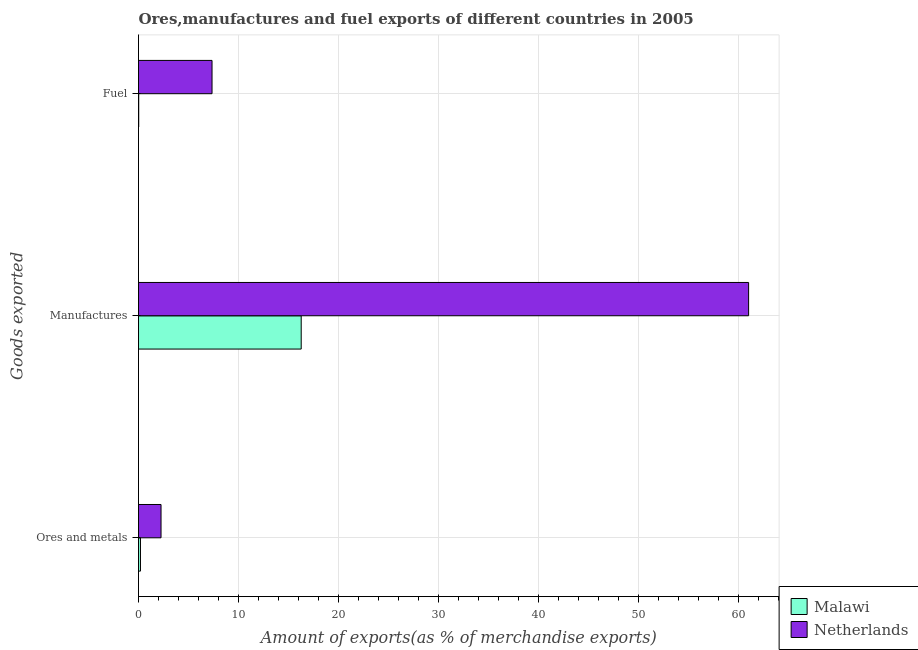How many different coloured bars are there?
Your answer should be very brief. 2. Are the number of bars on each tick of the Y-axis equal?
Your response must be concise. Yes. How many bars are there on the 3rd tick from the top?
Your answer should be very brief. 2. What is the label of the 2nd group of bars from the top?
Provide a succinct answer. Manufactures. What is the percentage of ores and metals exports in Netherlands?
Give a very brief answer. 2.25. Across all countries, what is the maximum percentage of ores and metals exports?
Give a very brief answer. 2.25. Across all countries, what is the minimum percentage of manufactures exports?
Your response must be concise. 16.27. In which country was the percentage of manufactures exports minimum?
Your answer should be compact. Malawi. What is the total percentage of ores and metals exports in the graph?
Make the answer very short. 2.45. What is the difference between the percentage of manufactures exports in Netherlands and that in Malawi?
Keep it short and to the point. 44.75. What is the difference between the percentage of fuel exports in Netherlands and the percentage of ores and metals exports in Malawi?
Provide a short and direct response. 7.16. What is the average percentage of fuel exports per country?
Your answer should be compact. 3.69. What is the difference between the percentage of manufactures exports and percentage of fuel exports in Netherlands?
Your answer should be very brief. 53.67. In how many countries, is the percentage of fuel exports greater than 16 %?
Make the answer very short. 0. What is the ratio of the percentage of fuel exports in Netherlands to that in Malawi?
Keep it short and to the point. 359.33. What is the difference between the highest and the second highest percentage of manufactures exports?
Keep it short and to the point. 44.75. What is the difference between the highest and the lowest percentage of fuel exports?
Keep it short and to the point. 7.33. What does the 2nd bar from the top in Ores and metals represents?
Offer a very short reply. Malawi. How many bars are there?
Give a very brief answer. 6. Are all the bars in the graph horizontal?
Your response must be concise. Yes. How many countries are there in the graph?
Provide a succinct answer. 2. How are the legend labels stacked?
Offer a terse response. Vertical. What is the title of the graph?
Your response must be concise. Ores,manufactures and fuel exports of different countries in 2005. What is the label or title of the X-axis?
Offer a terse response. Amount of exports(as % of merchandise exports). What is the label or title of the Y-axis?
Your answer should be compact. Goods exported. What is the Amount of exports(as % of merchandise exports) of Malawi in Ores and metals?
Provide a succinct answer. 0.2. What is the Amount of exports(as % of merchandise exports) of Netherlands in Ores and metals?
Give a very brief answer. 2.25. What is the Amount of exports(as % of merchandise exports) in Malawi in Manufactures?
Your answer should be compact. 16.27. What is the Amount of exports(as % of merchandise exports) of Netherlands in Manufactures?
Offer a terse response. 61.02. What is the Amount of exports(as % of merchandise exports) in Malawi in Fuel?
Make the answer very short. 0.02. What is the Amount of exports(as % of merchandise exports) in Netherlands in Fuel?
Make the answer very short. 7.35. Across all Goods exported, what is the maximum Amount of exports(as % of merchandise exports) of Malawi?
Offer a terse response. 16.27. Across all Goods exported, what is the maximum Amount of exports(as % of merchandise exports) in Netherlands?
Make the answer very short. 61.02. Across all Goods exported, what is the minimum Amount of exports(as % of merchandise exports) in Malawi?
Provide a succinct answer. 0.02. Across all Goods exported, what is the minimum Amount of exports(as % of merchandise exports) in Netherlands?
Make the answer very short. 2.25. What is the total Amount of exports(as % of merchandise exports) of Malawi in the graph?
Keep it short and to the point. 16.49. What is the total Amount of exports(as % of merchandise exports) in Netherlands in the graph?
Keep it short and to the point. 70.63. What is the difference between the Amount of exports(as % of merchandise exports) of Malawi in Ores and metals and that in Manufactures?
Your response must be concise. -16.08. What is the difference between the Amount of exports(as % of merchandise exports) in Netherlands in Ores and metals and that in Manufactures?
Your answer should be very brief. -58.77. What is the difference between the Amount of exports(as % of merchandise exports) in Malawi in Ores and metals and that in Fuel?
Keep it short and to the point. 0.18. What is the difference between the Amount of exports(as % of merchandise exports) of Netherlands in Ores and metals and that in Fuel?
Ensure brevity in your answer.  -5.1. What is the difference between the Amount of exports(as % of merchandise exports) of Malawi in Manufactures and that in Fuel?
Your response must be concise. 16.25. What is the difference between the Amount of exports(as % of merchandise exports) in Netherlands in Manufactures and that in Fuel?
Your answer should be compact. 53.67. What is the difference between the Amount of exports(as % of merchandise exports) in Malawi in Ores and metals and the Amount of exports(as % of merchandise exports) in Netherlands in Manufactures?
Offer a terse response. -60.83. What is the difference between the Amount of exports(as % of merchandise exports) of Malawi in Ores and metals and the Amount of exports(as % of merchandise exports) of Netherlands in Fuel?
Make the answer very short. -7.16. What is the difference between the Amount of exports(as % of merchandise exports) in Malawi in Manufactures and the Amount of exports(as % of merchandise exports) in Netherlands in Fuel?
Make the answer very short. 8.92. What is the average Amount of exports(as % of merchandise exports) in Malawi per Goods exported?
Provide a succinct answer. 5.5. What is the average Amount of exports(as % of merchandise exports) in Netherlands per Goods exported?
Give a very brief answer. 23.54. What is the difference between the Amount of exports(as % of merchandise exports) in Malawi and Amount of exports(as % of merchandise exports) in Netherlands in Ores and metals?
Offer a very short reply. -2.06. What is the difference between the Amount of exports(as % of merchandise exports) of Malawi and Amount of exports(as % of merchandise exports) of Netherlands in Manufactures?
Your answer should be compact. -44.75. What is the difference between the Amount of exports(as % of merchandise exports) of Malawi and Amount of exports(as % of merchandise exports) of Netherlands in Fuel?
Give a very brief answer. -7.33. What is the ratio of the Amount of exports(as % of merchandise exports) of Malawi in Ores and metals to that in Manufactures?
Your response must be concise. 0.01. What is the ratio of the Amount of exports(as % of merchandise exports) in Netherlands in Ores and metals to that in Manufactures?
Keep it short and to the point. 0.04. What is the ratio of the Amount of exports(as % of merchandise exports) of Malawi in Ores and metals to that in Fuel?
Provide a succinct answer. 9.56. What is the ratio of the Amount of exports(as % of merchandise exports) in Netherlands in Ores and metals to that in Fuel?
Keep it short and to the point. 0.31. What is the ratio of the Amount of exports(as % of merchandise exports) of Malawi in Manufactures to that in Fuel?
Your answer should be compact. 795.18. What is the ratio of the Amount of exports(as % of merchandise exports) of Netherlands in Manufactures to that in Fuel?
Offer a terse response. 8.3. What is the difference between the highest and the second highest Amount of exports(as % of merchandise exports) in Malawi?
Give a very brief answer. 16.08. What is the difference between the highest and the second highest Amount of exports(as % of merchandise exports) of Netherlands?
Give a very brief answer. 53.67. What is the difference between the highest and the lowest Amount of exports(as % of merchandise exports) in Malawi?
Give a very brief answer. 16.25. What is the difference between the highest and the lowest Amount of exports(as % of merchandise exports) of Netherlands?
Provide a succinct answer. 58.77. 